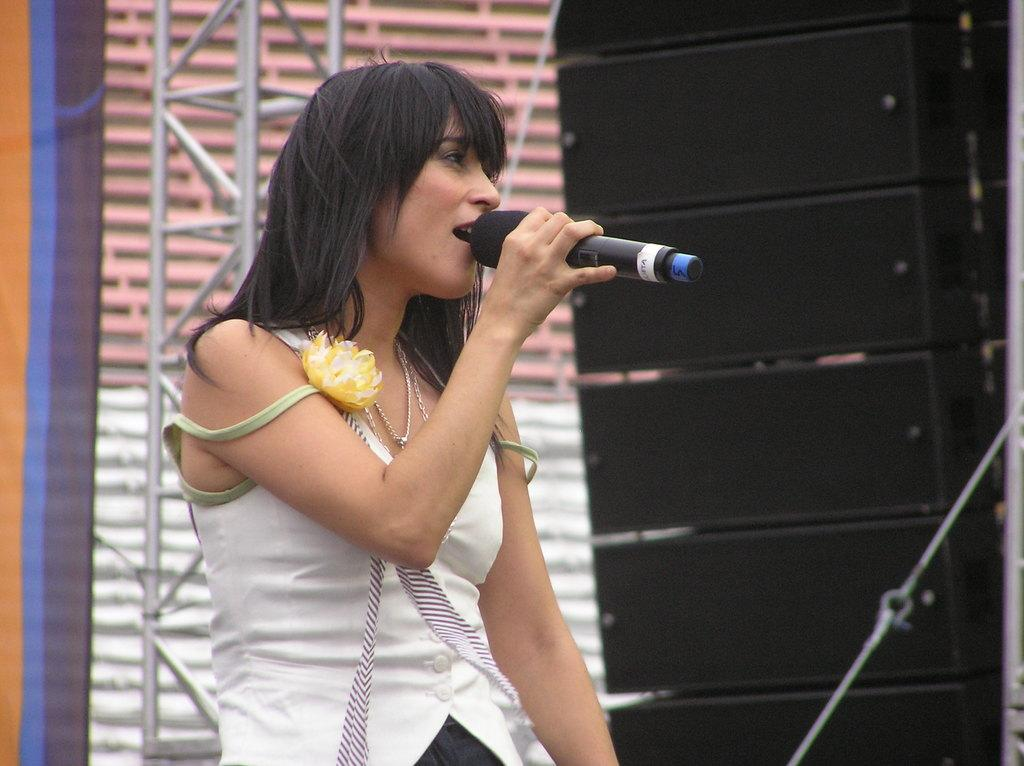Who is the main subject in the picture? There is a woman in the picture. What is the woman doing in the image? The woman is standing and singing. What object is present in the picture that might be related to the woman's activity? There is a microphone in the picture. What type of vest is the woman wearing in the image? There is no vest visible in the image; the woman is not wearing any clothing item mentioned in the provided facts. 